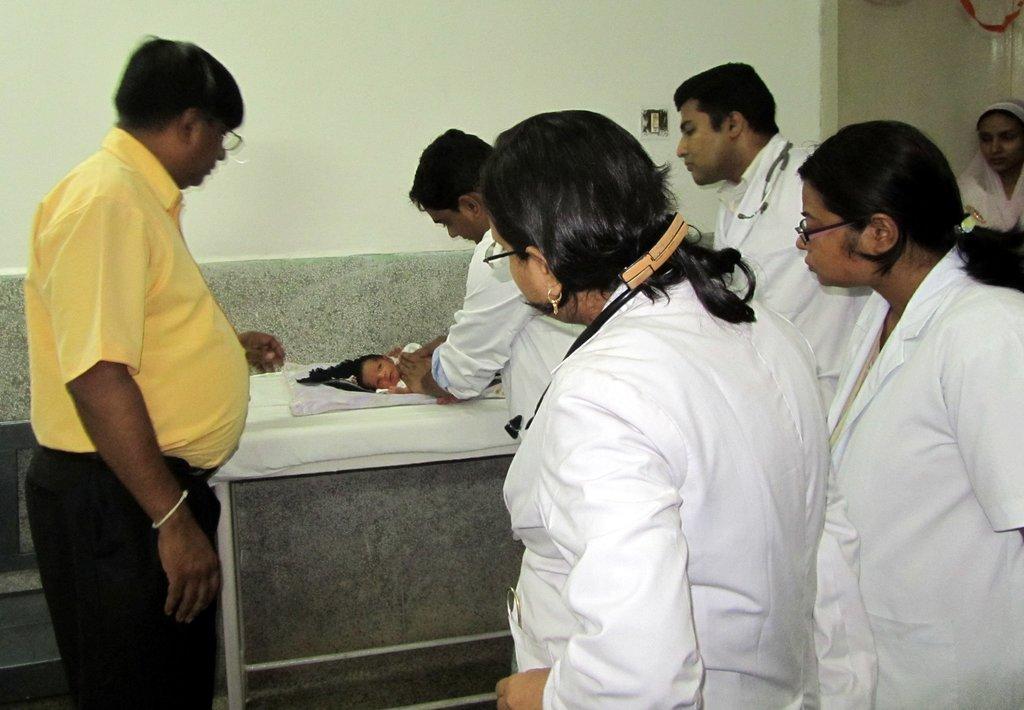How would you summarize this image in a sentence or two? In this image I can see group of people are standing among them these people are wearing white color clothes. In the background I can see a baby on a white color surface and a white color wall. 